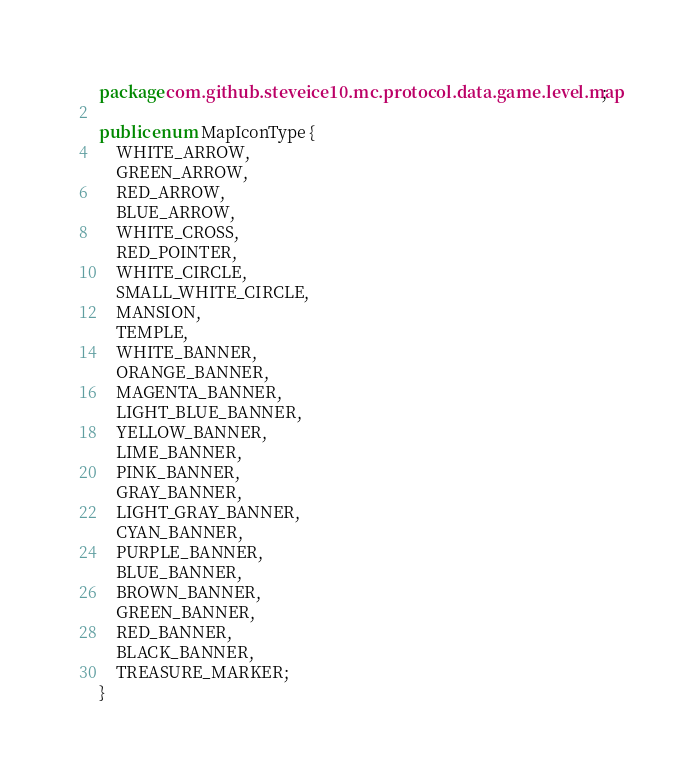Convert code to text. <code><loc_0><loc_0><loc_500><loc_500><_Java_>package com.github.steveice10.mc.protocol.data.game.level.map;

public enum MapIconType {
    WHITE_ARROW,
    GREEN_ARROW,
    RED_ARROW,
    BLUE_ARROW,
    WHITE_CROSS,
    RED_POINTER,
    WHITE_CIRCLE,
    SMALL_WHITE_CIRCLE,
    MANSION,
    TEMPLE,
    WHITE_BANNER,
    ORANGE_BANNER,
    MAGENTA_BANNER,
    LIGHT_BLUE_BANNER,
    YELLOW_BANNER,
    LIME_BANNER,
    PINK_BANNER,
    GRAY_BANNER,
    LIGHT_GRAY_BANNER,
    CYAN_BANNER,
    PURPLE_BANNER,
    BLUE_BANNER,
    BROWN_BANNER,
    GREEN_BANNER,
    RED_BANNER,
    BLACK_BANNER,
    TREASURE_MARKER;
}
</code> 